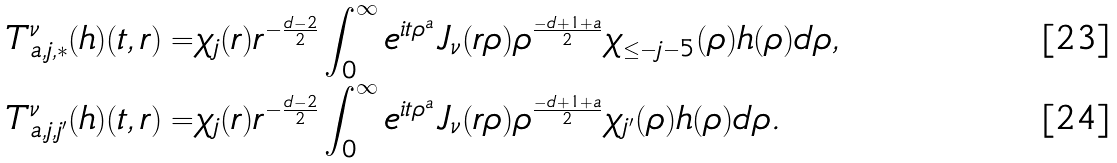<formula> <loc_0><loc_0><loc_500><loc_500>T _ { a , j , * } ^ { \nu } ( h ) ( t , r ) = & \chi _ { j } ( r ) r ^ { - \frac { d - 2 } { 2 } } \int _ { 0 } ^ { \infty } e ^ { i t \rho ^ { a } } J _ { \nu } ( r \rho ) \rho ^ { \frac { - d + 1 + a } { 2 } } \chi _ { \leq - j - 5 } ( \rho ) h ( \rho ) d \rho , \\ T _ { a , j , j ^ { \prime } } ^ { \nu } ( h ) ( t , r ) = & \chi _ { j } ( r ) r ^ { - \frac { d - 2 } { 2 } } \int _ { 0 } ^ { \infty } e ^ { i t \rho ^ { a } } J _ { \nu } ( r \rho ) \rho ^ { \frac { - d + 1 + a } { 2 } } \chi _ { j ^ { \prime } } ( \rho ) h ( \rho ) d \rho .</formula> 